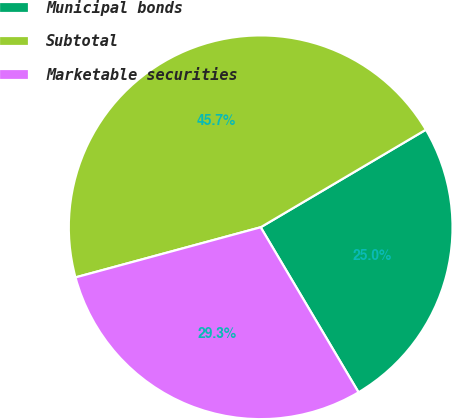Convert chart. <chart><loc_0><loc_0><loc_500><loc_500><pie_chart><fcel>Municipal bonds<fcel>Subtotal<fcel>Marketable securities<nl><fcel>24.97%<fcel>45.72%<fcel>29.31%<nl></chart> 